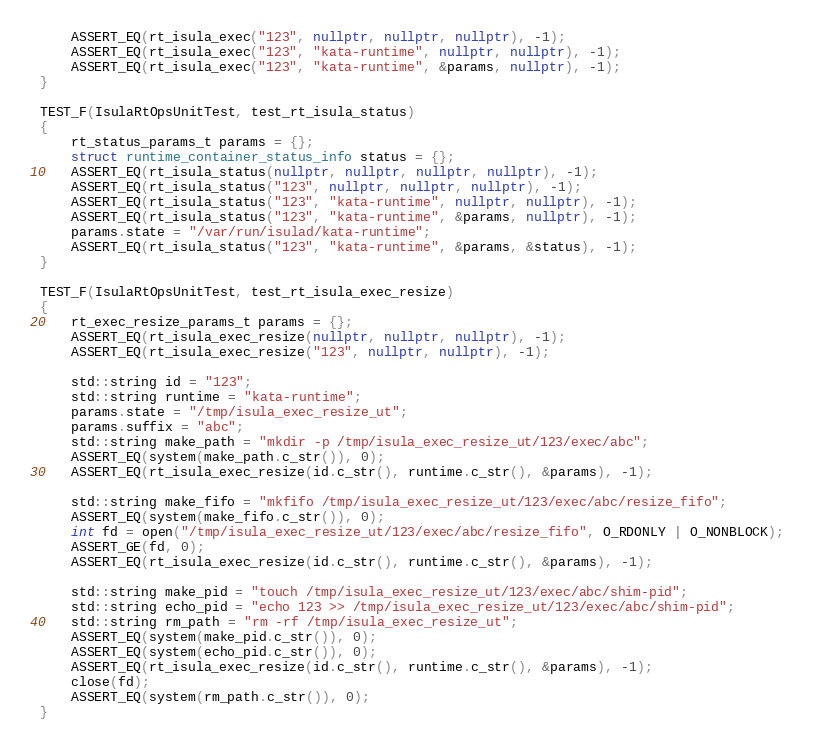Convert code to text. <code><loc_0><loc_0><loc_500><loc_500><_C++_>    ASSERT_EQ(rt_isula_exec("123", nullptr, nullptr, nullptr), -1);
    ASSERT_EQ(rt_isula_exec("123", "kata-runtime", nullptr, nullptr), -1);
    ASSERT_EQ(rt_isula_exec("123", "kata-runtime", &params, nullptr), -1);
}

TEST_F(IsulaRtOpsUnitTest, test_rt_isula_status)
{
    rt_status_params_t params = {};
    struct runtime_container_status_info status = {};
    ASSERT_EQ(rt_isula_status(nullptr, nullptr, nullptr, nullptr), -1);
    ASSERT_EQ(rt_isula_status("123", nullptr, nullptr, nullptr), -1);
    ASSERT_EQ(rt_isula_status("123", "kata-runtime", nullptr, nullptr), -1);
    ASSERT_EQ(rt_isula_status("123", "kata-runtime", &params, nullptr), -1);
    params.state = "/var/run/isulad/kata-runtime";
    ASSERT_EQ(rt_isula_status("123", "kata-runtime", &params, &status), -1);
}

TEST_F(IsulaRtOpsUnitTest, test_rt_isula_exec_resize)
{
    rt_exec_resize_params_t params = {};
    ASSERT_EQ(rt_isula_exec_resize(nullptr, nullptr, nullptr), -1);
    ASSERT_EQ(rt_isula_exec_resize("123", nullptr, nullptr), -1);

    std::string id = "123";
    std::string runtime = "kata-runtime";
    params.state = "/tmp/isula_exec_resize_ut";
    params.suffix = "abc";
    std::string make_path = "mkdir -p /tmp/isula_exec_resize_ut/123/exec/abc";
    ASSERT_EQ(system(make_path.c_str()), 0);
    ASSERT_EQ(rt_isula_exec_resize(id.c_str(), runtime.c_str(), &params), -1);

    std::string make_fifo = "mkfifo /tmp/isula_exec_resize_ut/123/exec/abc/resize_fifo";
    ASSERT_EQ(system(make_fifo.c_str()), 0);
    int fd = open("/tmp/isula_exec_resize_ut/123/exec/abc/resize_fifo", O_RDONLY | O_NONBLOCK);
    ASSERT_GE(fd, 0);
    ASSERT_EQ(rt_isula_exec_resize(id.c_str(), runtime.c_str(), &params), -1);

    std::string make_pid = "touch /tmp/isula_exec_resize_ut/123/exec/abc/shim-pid";
    std::string echo_pid = "echo 123 >> /tmp/isula_exec_resize_ut/123/exec/abc/shim-pid";
    std::string rm_path = "rm -rf /tmp/isula_exec_resize_ut";
    ASSERT_EQ(system(make_pid.c_str()), 0);
    ASSERT_EQ(system(echo_pid.c_str()), 0);
    ASSERT_EQ(rt_isula_exec_resize(id.c_str(), runtime.c_str(), &params), -1);
    close(fd);
    ASSERT_EQ(system(rm_path.c_str()), 0);
}
</code> 